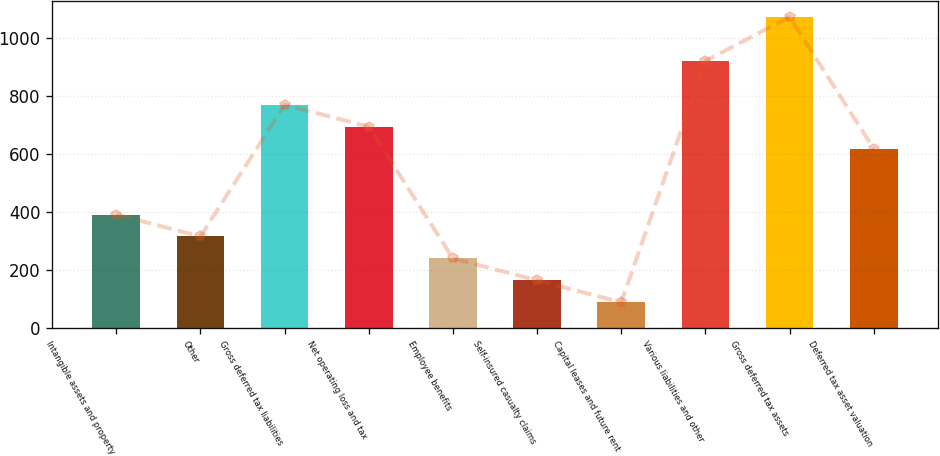Convert chart to OTSL. <chart><loc_0><loc_0><loc_500><loc_500><bar_chart><fcel>Intangible assets and property<fcel>Other<fcel>Gross deferred tax liabilities<fcel>Net operating loss and tax<fcel>Employee benefits<fcel>Self-insured casualty claims<fcel>Capital leases and future rent<fcel>Various liabilities and other<fcel>Gross deferred tax assets<fcel>Deferred tax asset valuation<nl><fcel>391.5<fcel>315.8<fcel>770<fcel>694.3<fcel>240.1<fcel>164.4<fcel>88.7<fcel>921.4<fcel>1072.8<fcel>618.6<nl></chart> 